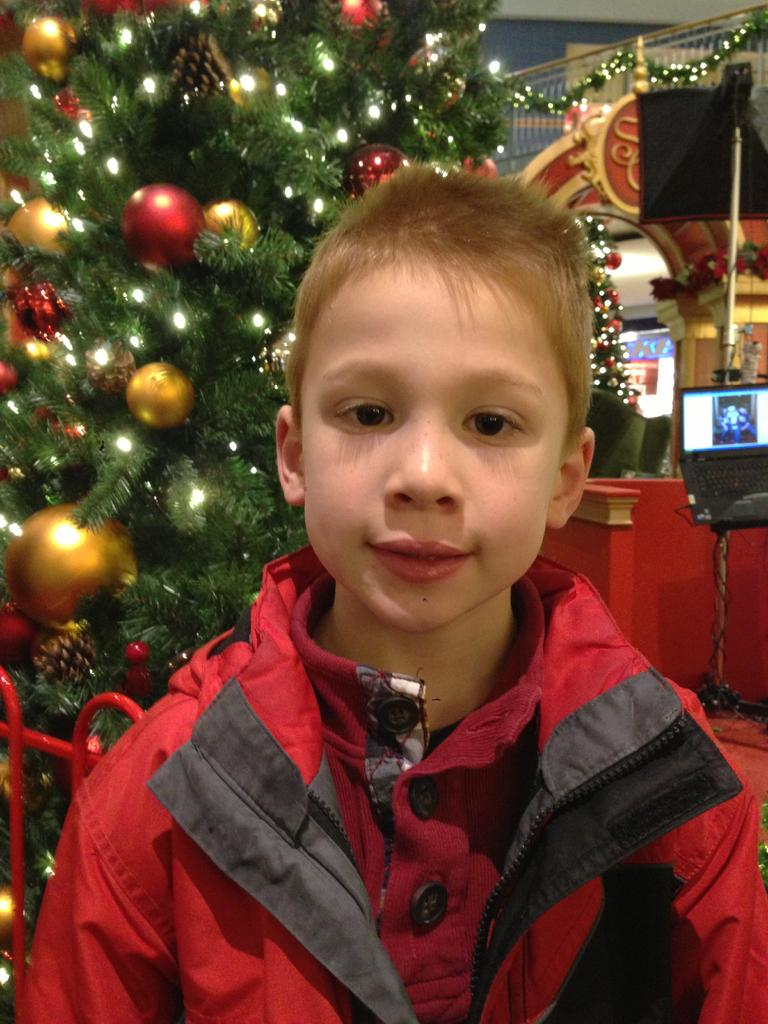Who is the main subject in the image? There is a boy in the image. What can be seen in the background of the image? There are Christmas trees, a laptop, railing, a pillar, and lights in the background of the image. Can you describe the objects in the background? There are other objects in the background of the image, but their specific details are not mentioned in the provided facts. What type of root is growing near the boy in the image? There is no root visible in the image; it features a boy and various objects in the background. 